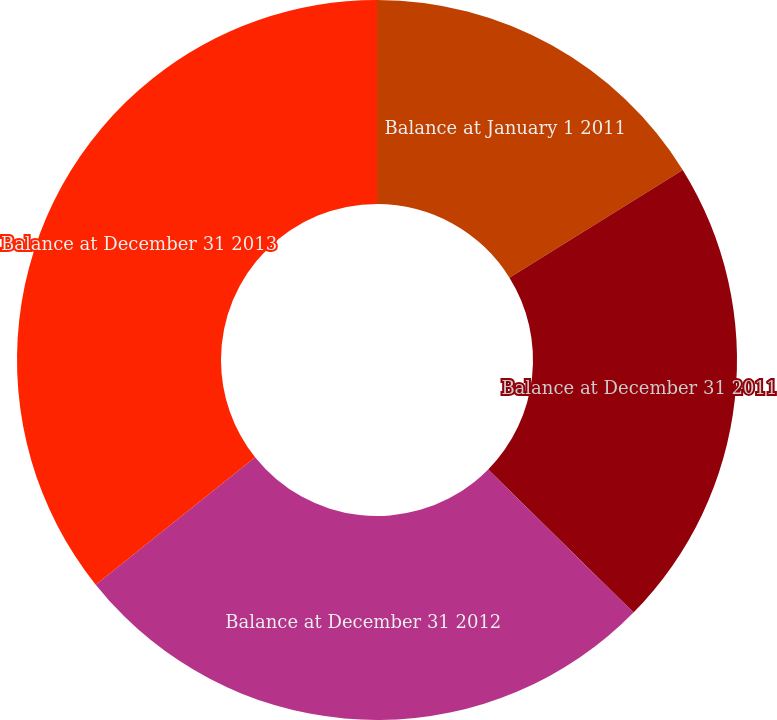Convert chart. <chart><loc_0><loc_0><loc_500><loc_500><pie_chart><fcel>Balance at January 1 2011<fcel>Balance at December 31 2011<fcel>Balance at December 31 2012<fcel>Balance at December 31 2013<nl><fcel>16.15%<fcel>21.23%<fcel>26.9%<fcel>35.73%<nl></chart> 